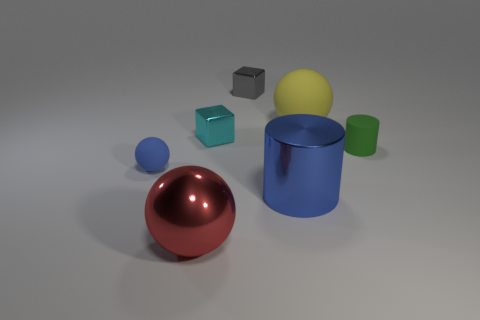Do the green rubber object and the gray metal block have the same size? No, they do not. The green rubber object is cylindrical and seems to be larger in both height and diameter when compared to the smaller gray metal block. 